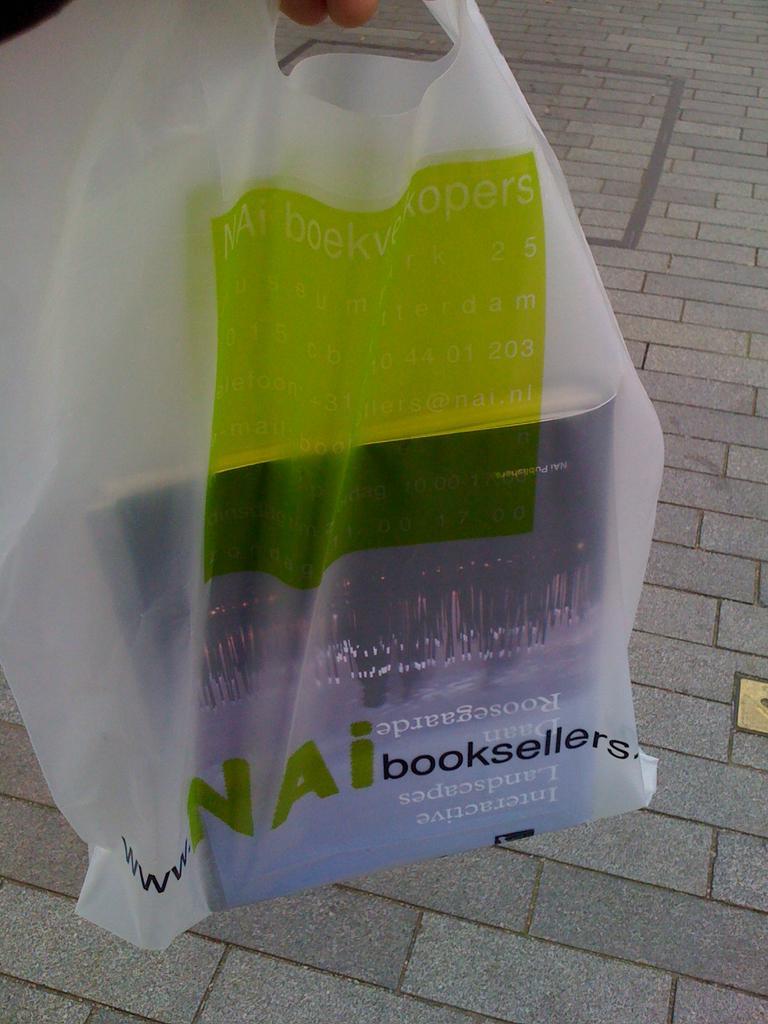How would you summarize this image in a sentence or two? In this picture we can see a book in the plastic cover. 